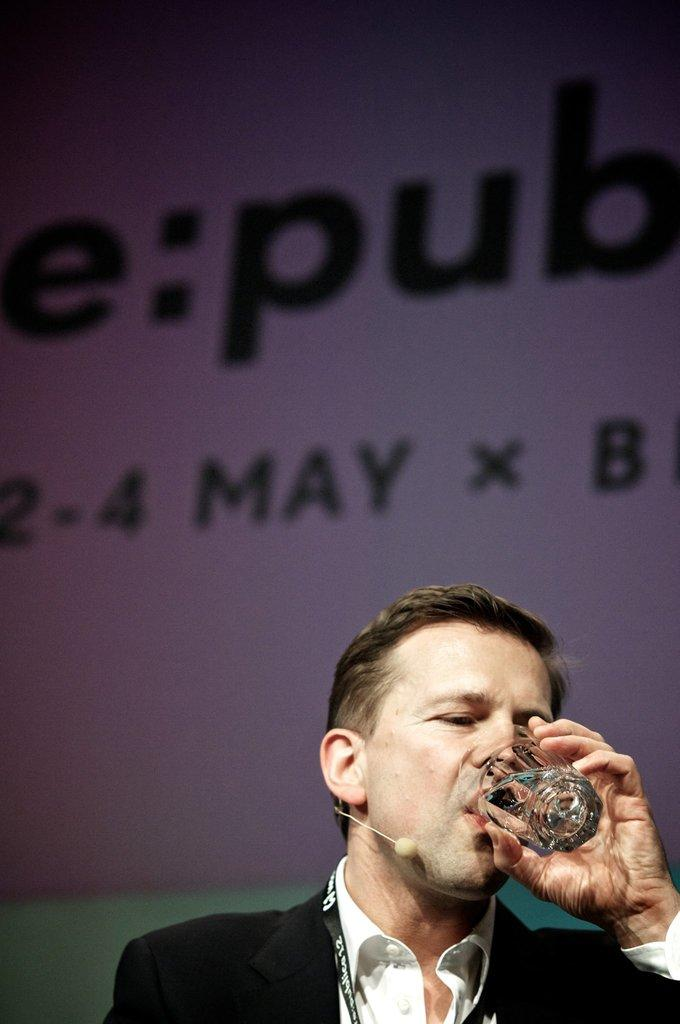What is the person in the image wearing? The person is wearing a black suit in the image. What is the person holding in their hand? The person is holding a glass with one hand. What is the person doing with the glass? The person is drinking water from the glass. What can be seen in the background of the image? There is a white hoarding in the background of the image. Where is the hoarding located in relation to the wall? The hoarding is near a wall. What type of cream can be seen on the person's face in the image? There is no cream visible on the person's face in the image. Is there a garden visible in the background of the image? No, there is no garden visible in the background of the image; only a white hoarding near a wall is present. 